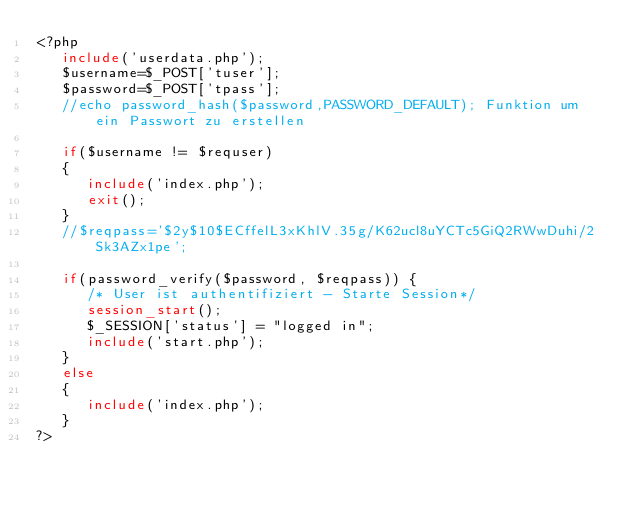<code> <loc_0><loc_0><loc_500><loc_500><_PHP_><?php
   include('userdata.php');
   $username=$_POST['tuser'];
   $password=$_POST['tpass'];
   //echo password_hash($password,PASSWORD_DEFAULT); Funktion um ein Passwort zu erstellen

   if($username != $requser)
   {
      include('index.php');
      exit();
   }
   //$reqpass='$2y$10$ECffelL3xKhlV.35g/K62ucl8uYCTc5GiQ2RWwDuhi/2Sk3AZx1pe';

   if(password_verify($password, $reqpass)) {
      /* User ist authentifiziert - Starte Session*/
      session_start();
      $_SESSION['status'] = "logged in";
      include('start.php');
   }
   else
   {
      include('index.php');
   }
?>
</code> 